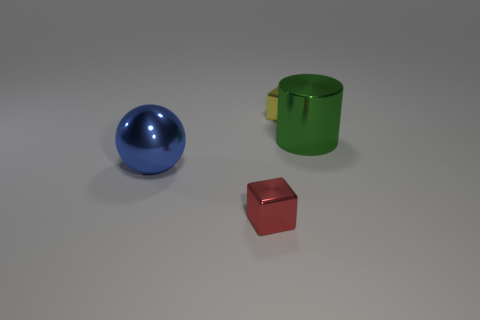Is the size of the red cube the same as the metal block that is behind the large blue metal thing?
Your answer should be compact. Yes. There is a metallic thing that is both in front of the yellow thing and behind the big metallic ball; what size is it?
Ensure brevity in your answer.  Large. Are there any small blocks of the same color as the ball?
Make the answer very short. No. What is the color of the big thing that is to the left of the tiny block that is behind the tiny red metal object?
Ensure brevity in your answer.  Blue. Is the number of red cubes on the right side of the tiny red thing less than the number of large shiny objects behind the metallic sphere?
Offer a very short reply. Yes. Do the metallic cylinder and the yellow thing have the same size?
Your answer should be compact. No. There is a metallic thing that is on the left side of the metallic cylinder and to the right of the red object; what is its shape?
Offer a very short reply. Cube. How many yellow things are the same material as the big sphere?
Your answer should be very brief. 1. How many big blue spheres are in front of the tiny object that is behind the red cube?
Your answer should be very brief. 1. What shape is the big thing that is right of the tiny object behind the shiny object left of the red metal block?
Your answer should be very brief. Cylinder. 